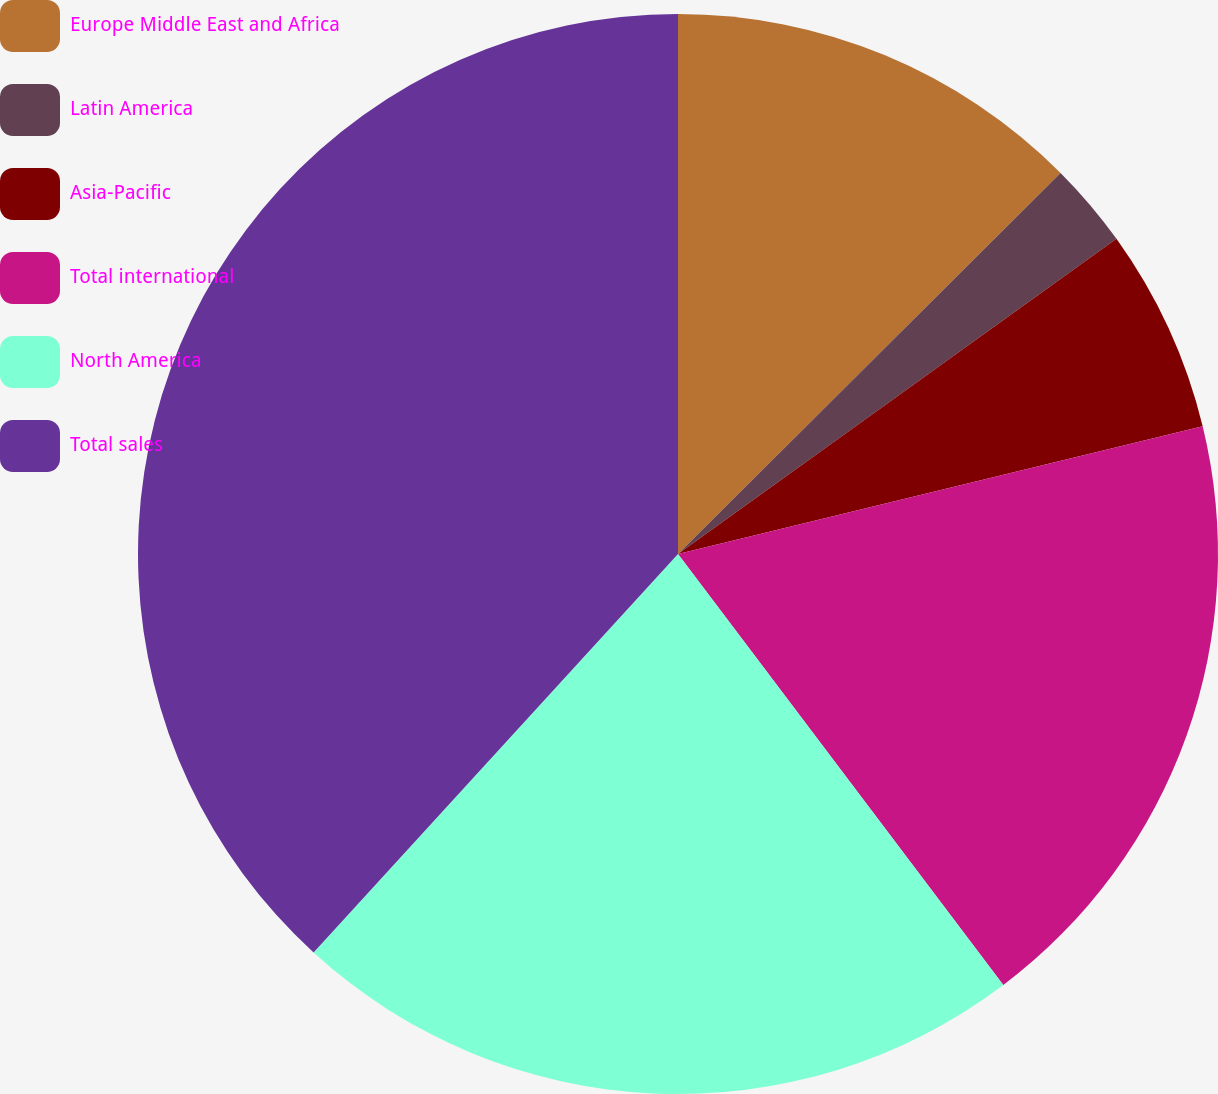Convert chart. <chart><loc_0><loc_0><loc_500><loc_500><pie_chart><fcel>Europe Middle East and Africa<fcel>Latin America<fcel>Asia-Pacific<fcel>Total international<fcel>North America<fcel>Total sales<nl><fcel>12.53%<fcel>2.55%<fcel>6.12%<fcel>18.51%<fcel>22.08%<fcel>38.21%<nl></chart> 